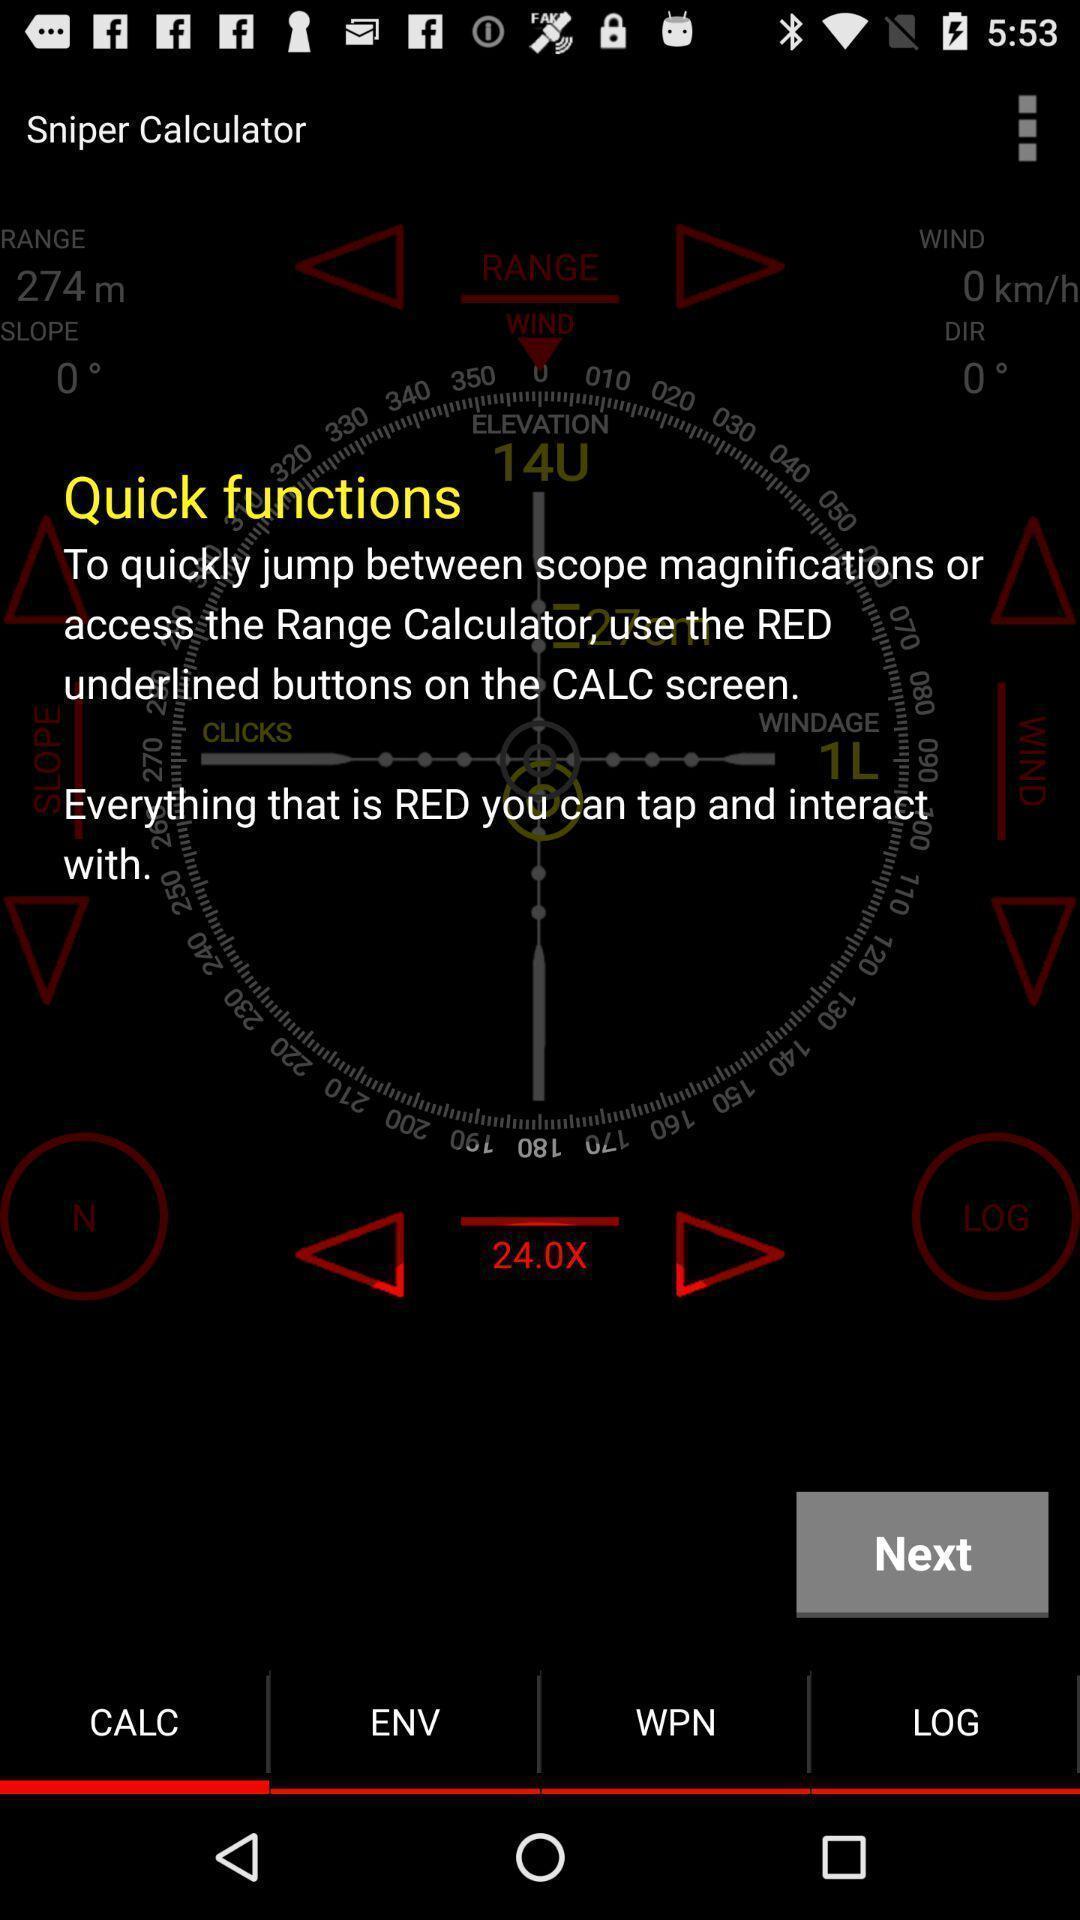Describe this image in words. Screen showing functions. 